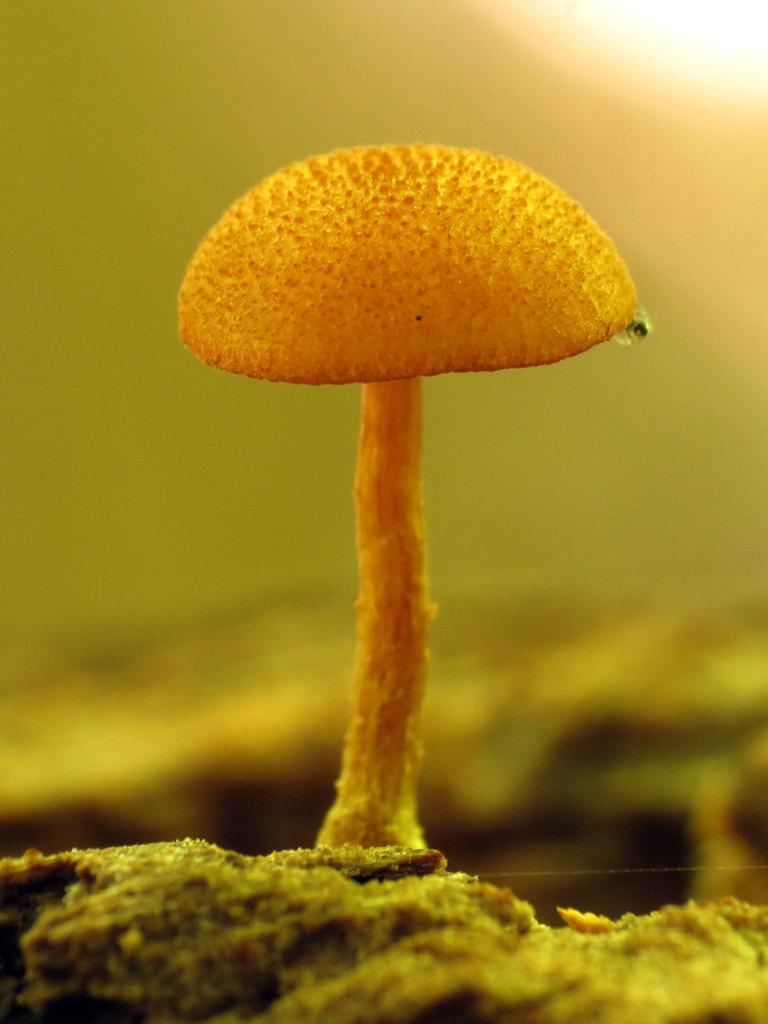What is the main subject of the image? There is a mushroom in the image. What can be seen beneath the mushroom? The ground is visible in the image. How would you describe the background of the image? The background of the image is blurred. What type of juice is being squeezed from the mushroom in the image? There is no juice being squeezed from the mushroom in the image, as it is a static object. 